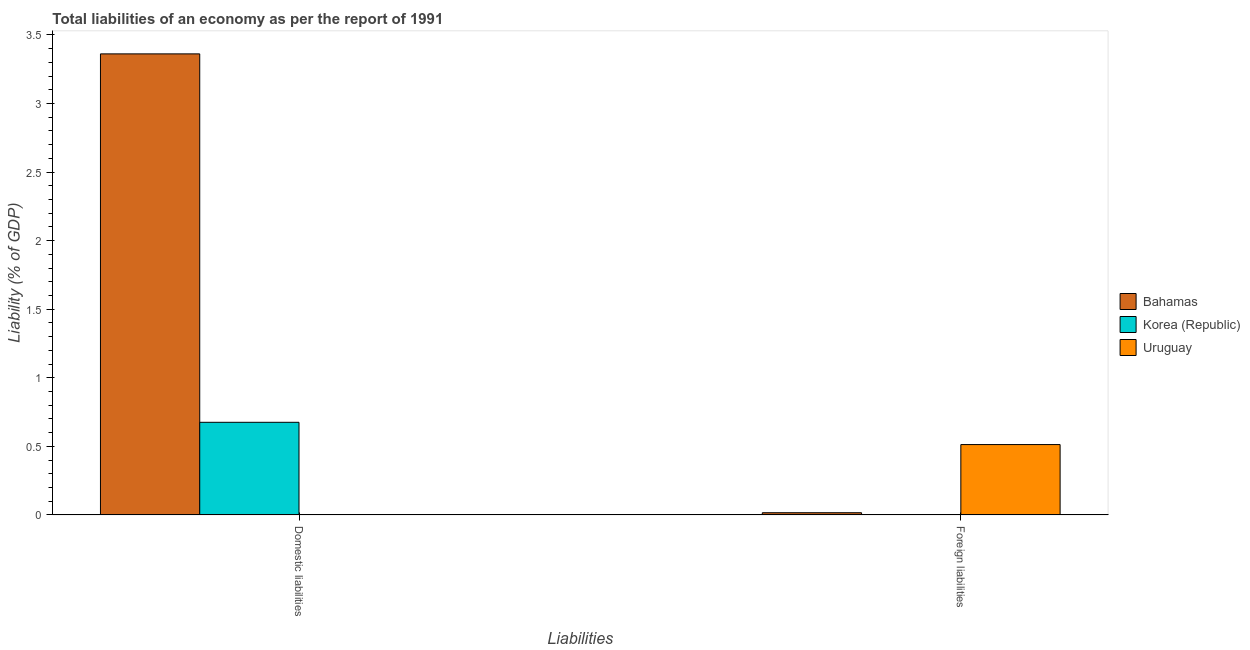How many different coloured bars are there?
Your answer should be very brief. 3. How many bars are there on the 1st tick from the left?
Your answer should be very brief. 2. How many bars are there on the 2nd tick from the right?
Make the answer very short. 2. What is the label of the 2nd group of bars from the left?
Your response must be concise. Foreign liabilities. What is the incurrence of domestic liabilities in Uruguay?
Provide a succinct answer. 0. Across all countries, what is the maximum incurrence of domestic liabilities?
Your response must be concise. 3.36. Across all countries, what is the minimum incurrence of domestic liabilities?
Offer a terse response. 0. In which country was the incurrence of domestic liabilities maximum?
Make the answer very short. Bahamas. What is the total incurrence of foreign liabilities in the graph?
Your response must be concise. 0.53. What is the difference between the incurrence of domestic liabilities in Bahamas and that in Korea (Republic)?
Provide a succinct answer. 2.69. What is the difference between the incurrence of foreign liabilities in Uruguay and the incurrence of domestic liabilities in Bahamas?
Offer a terse response. -2.85. What is the average incurrence of domestic liabilities per country?
Provide a succinct answer. 1.35. What is the difference between the incurrence of domestic liabilities and incurrence of foreign liabilities in Bahamas?
Make the answer very short. 3.35. In how many countries, is the incurrence of foreign liabilities greater than 1.3 %?
Offer a very short reply. 0. What is the ratio of the incurrence of domestic liabilities in Korea (Republic) to that in Bahamas?
Offer a terse response. 0.2. How many bars are there?
Make the answer very short. 4. How many countries are there in the graph?
Make the answer very short. 3. Are the values on the major ticks of Y-axis written in scientific E-notation?
Offer a very short reply. No. Does the graph contain any zero values?
Your answer should be compact. Yes. Does the graph contain grids?
Ensure brevity in your answer.  No. Where does the legend appear in the graph?
Offer a very short reply. Center right. How many legend labels are there?
Make the answer very short. 3. What is the title of the graph?
Make the answer very short. Total liabilities of an economy as per the report of 1991. What is the label or title of the X-axis?
Provide a short and direct response. Liabilities. What is the label or title of the Y-axis?
Offer a very short reply. Liability (% of GDP). What is the Liability (% of GDP) in Bahamas in Domestic liabilities?
Your answer should be compact. 3.36. What is the Liability (% of GDP) in Korea (Republic) in Domestic liabilities?
Keep it short and to the point. 0.68. What is the Liability (% of GDP) of Uruguay in Domestic liabilities?
Keep it short and to the point. 0. What is the Liability (% of GDP) in Bahamas in Foreign liabilities?
Your answer should be compact. 0.02. What is the Liability (% of GDP) of Uruguay in Foreign liabilities?
Your response must be concise. 0.51. Across all Liabilities, what is the maximum Liability (% of GDP) of Bahamas?
Provide a succinct answer. 3.36. Across all Liabilities, what is the maximum Liability (% of GDP) in Korea (Republic)?
Make the answer very short. 0.68. Across all Liabilities, what is the maximum Liability (% of GDP) in Uruguay?
Keep it short and to the point. 0.51. Across all Liabilities, what is the minimum Liability (% of GDP) of Bahamas?
Offer a terse response. 0.02. Across all Liabilities, what is the minimum Liability (% of GDP) in Korea (Republic)?
Your answer should be compact. 0. What is the total Liability (% of GDP) of Bahamas in the graph?
Your answer should be compact. 3.38. What is the total Liability (% of GDP) of Korea (Republic) in the graph?
Your answer should be very brief. 0.68. What is the total Liability (% of GDP) in Uruguay in the graph?
Your response must be concise. 0.51. What is the difference between the Liability (% of GDP) of Bahamas in Domestic liabilities and that in Foreign liabilities?
Ensure brevity in your answer.  3.35. What is the difference between the Liability (% of GDP) of Bahamas in Domestic liabilities and the Liability (% of GDP) of Uruguay in Foreign liabilities?
Provide a short and direct response. 2.85. What is the difference between the Liability (% of GDP) in Korea (Republic) in Domestic liabilities and the Liability (% of GDP) in Uruguay in Foreign liabilities?
Provide a short and direct response. 0.16. What is the average Liability (% of GDP) in Bahamas per Liabilities?
Offer a terse response. 1.69. What is the average Liability (% of GDP) in Korea (Republic) per Liabilities?
Offer a terse response. 0.34. What is the average Liability (% of GDP) of Uruguay per Liabilities?
Your response must be concise. 0.26. What is the difference between the Liability (% of GDP) in Bahamas and Liability (% of GDP) in Korea (Republic) in Domestic liabilities?
Provide a succinct answer. 2.69. What is the difference between the Liability (% of GDP) of Bahamas and Liability (% of GDP) of Uruguay in Foreign liabilities?
Your answer should be very brief. -0.5. What is the ratio of the Liability (% of GDP) of Bahamas in Domestic liabilities to that in Foreign liabilities?
Give a very brief answer. 209.2. What is the difference between the highest and the second highest Liability (% of GDP) of Bahamas?
Provide a short and direct response. 3.35. What is the difference between the highest and the lowest Liability (% of GDP) in Bahamas?
Your answer should be very brief. 3.35. What is the difference between the highest and the lowest Liability (% of GDP) of Korea (Republic)?
Keep it short and to the point. 0.68. What is the difference between the highest and the lowest Liability (% of GDP) of Uruguay?
Provide a short and direct response. 0.51. 